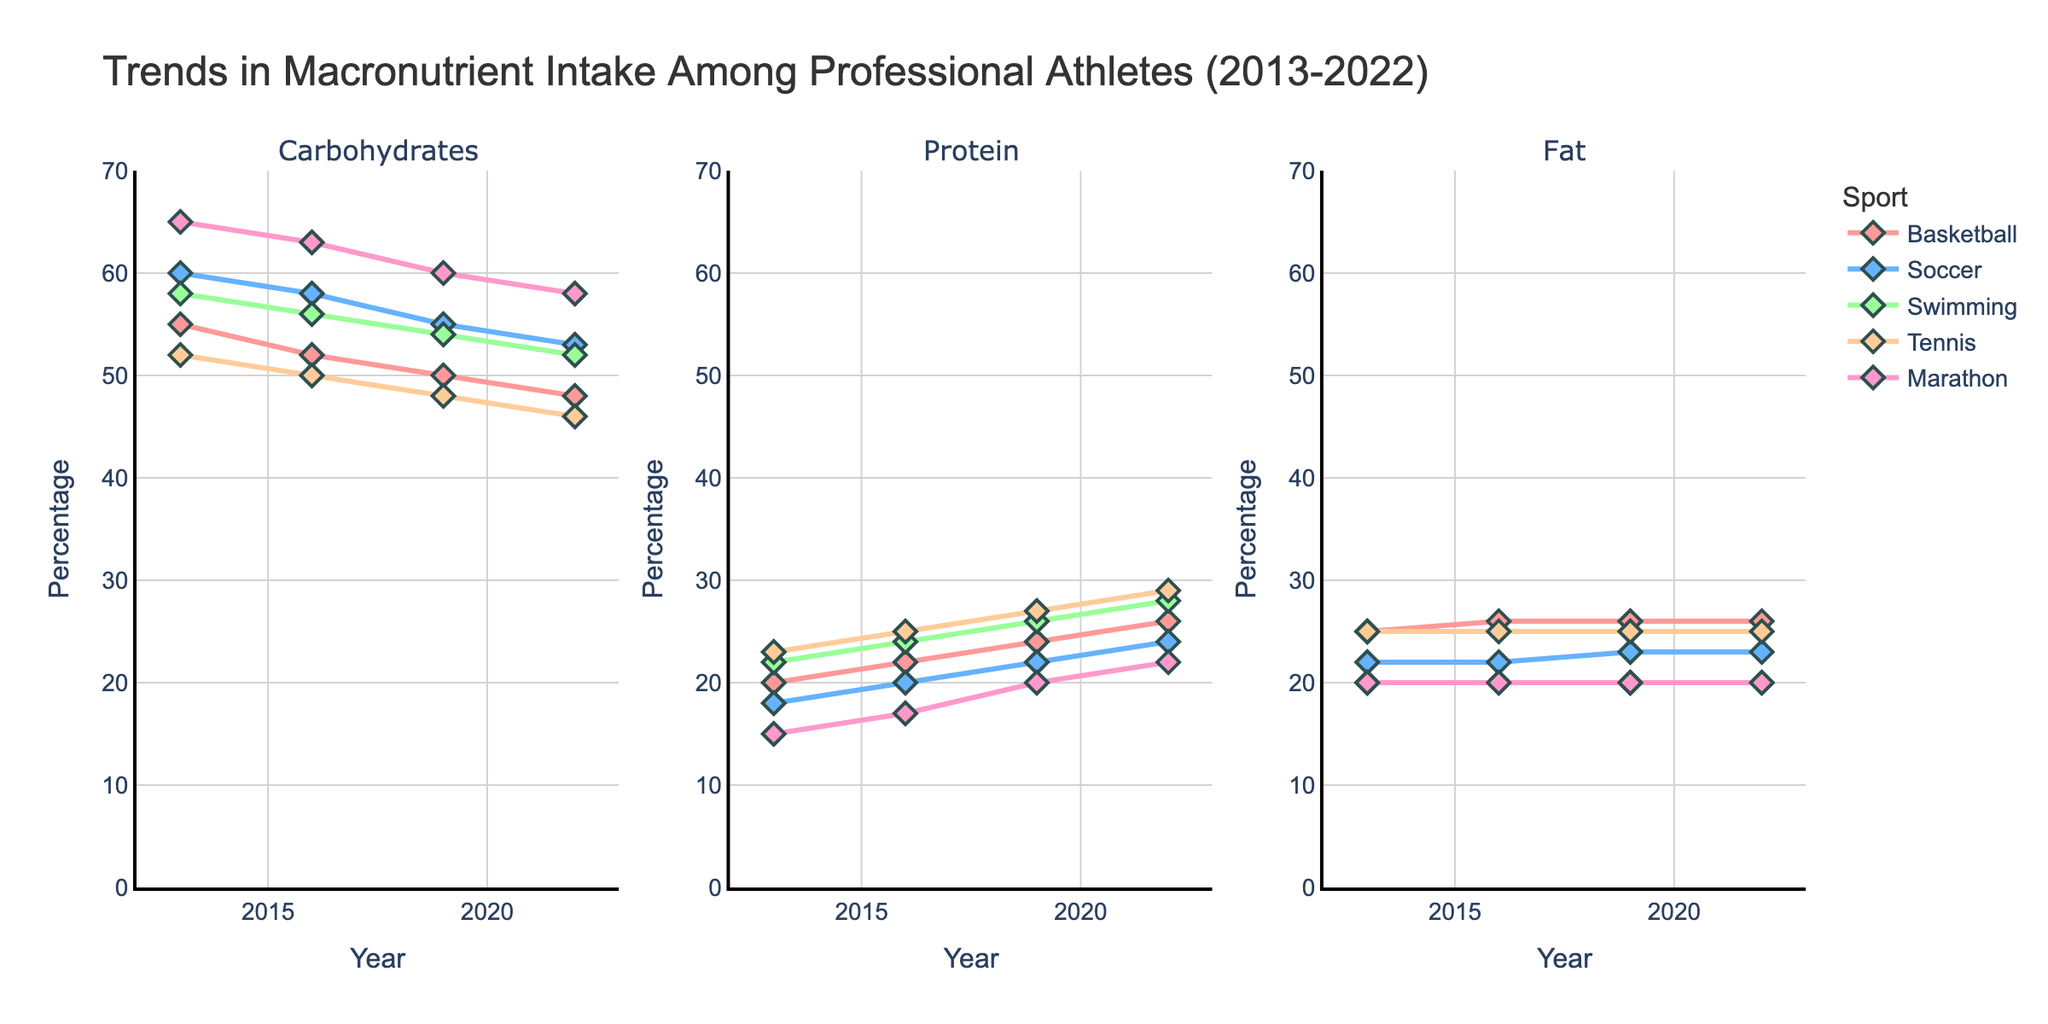What trend in carbohydrate intake can be observed for basketball players from 2013 to 2022? By analyzing the carbohydrates subplot, observe the basketball line (red). Starting at 55% in 2013, it decreases over the years, reaching 48% in 2022.
Answer: Decreasing Which sport showed the highest protein intake in 2022? In the protein subplot, compare the endpoints of different sport lines for 2022. The highest point is for swimming at 28%.
Answer: Swimming Compare the fat intake trends for tennis and soccer from 2013 to 2022. Look at the endpoints for tennis (25%) and soccer (23%) in the fat subplot. Both sports show a stable trend with little to no change across the years.
Answer: Both stable Calculate the average carbohydrate intake for marathon runners over the decade. Sum the carbohydrate percentages for marathon (65+63+60+58) and divide by the number of data points (4). The average is (65+63+60+58) / 4 = 246 / 4 = 61.5%.
Answer: 61.5% Between soccer and swimming, which showed a greater increase in protein intake from 2013 to 2022? Check the increase for soccer from 18% to 24% (+6%) and for swimming from 22% to 28% (+6%). Both show an equal increase.
Answer: Equal Identify the sport with the smallest change in fat intake over the decade. Observe the fat subplot and compare changes for each sport. Tennis and swimming show no change, each staying at 25% and 20%, respectively.
Answer: Swimming and Tennis Did the carbohydrate intake for any sport increase between 2013 and 2022? Check the carbohydrate subplot for any increasing trends. All sport lines are either decreasing or stable.
Answer: No What is the total protein intake for basketball and soccer combined in 2016? Add the protein percentages for basketball (22%) and soccer (20%) in 2016. The total is 22 + 20 = 42%.
Answer: 42% Which sport had a carbohydrate intake closest to 50% in 2019? Check the carbohydrate subplot for each sport line in 2019. Both basketball and tennis have 50% and 48%, respectively. Basketball is closest to 50%.
Answer: Basketball 